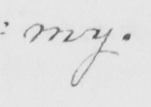What does this handwritten line say? : my . 